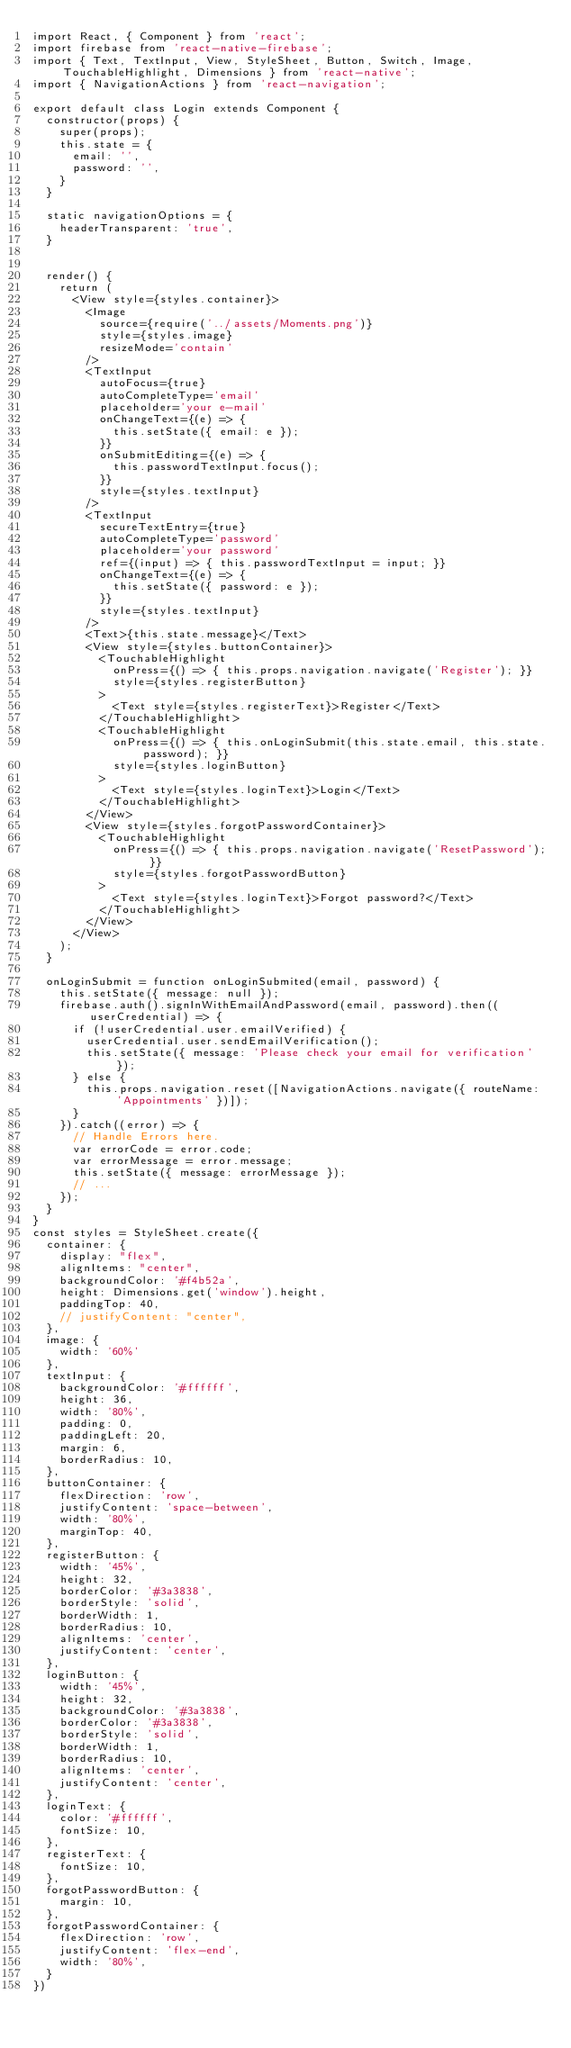<code> <loc_0><loc_0><loc_500><loc_500><_JavaScript_>import React, { Component } from 'react';
import firebase from 'react-native-firebase';
import { Text, TextInput, View, StyleSheet, Button, Switch, Image, TouchableHighlight, Dimensions } from 'react-native';
import { NavigationActions } from 'react-navigation';

export default class Login extends Component {
  constructor(props) {
    super(props);
    this.state = {
      email: '',
      password: '',
    }
  }

  static navigationOptions = {
    headerTransparent: 'true',
  }


  render() {
    return (
      <View style={styles.container}>
        <Image
          source={require('../assets/Moments.png')}
          style={styles.image}
          resizeMode='contain'
        />
        <TextInput
          autoFocus={true}
          autoCompleteType='email'
          placeholder='your e-mail'
          onChangeText={(e) => {
            this.setState({ email: e });
          }}
          onSubmitEditing={(e) => {
            this.passwordTextInput.focus();
          }}
          style={styles.textInput}
        />
        <TextInput
          secureTextEntry={true}
          autoCompleteType='password'
          placeholder='your password'
          ref={(input) => { this.passwordTextInput = input; }}
          onChangeText={(e) => {
            this.setState({ password: e });
          }}
          style={styles.textInput}
        />
        <Text>{this.state.message}</Text>
        <View style={styles.buttonContainer}>
          <TouchableHighlight
            onPress={() => { this.props.navigation.navigate('Register'); }}
            style={styles.registerButton}
          >
            <Text style={styles.registerText}>Register</Text>
          </TouchableHighlight>
          <TouchableHighlight
            onPress={() => { this.onLoginSubmit(this.state.email, this.state.password); }}
            style={styles.loginButton}
          >
            <Text style={styles.loginText}>Login</Text>
          </TouchableHighlight>
        </View>
        <View style={styles.forgotPasswordContainer}>
          <TouchableHighlight
            onPress={() => { this.props.navigation.navigate('ResetPassword'); }}
            style={styles.forgotPasswordButton}
          >
            <Text style={styles.loginText}>Forgot password?</Text>
          </TouchableHighlight>
        </View>
      </View>
    );
  }

  onLoginSubmit = function onLoginSubmited(email, password) {
    this.setState({ message: null });
    firebase.auth().signInWithEmailAndPassword(email, password).then((userCredential) => {
      if (!userCredential.user.emailVerified) {
        userCredential.user.sendEmailVerification();
        this.setState({ message: 'Please check your email for verification' });
      } else {
        this.props.navigation.reset([NavigationActions.navigate({ routeName: 'Appointments' })]);
      }
    }).catch((error) => {
      // Handle Errors here.
      var errorCode = error.code;
      var errorMessage = error.message;
      this.setState({ message: errorMessage });
      // ...
    });
  }
}
const styles = StyleSheet.create({
  container: {
    display: "flex",
    alignItems: "center",
    backgroundColor: '#f4b52a',
    height: Dimensions.get('window').height,
    paddingTop: 40,
    // justifyContent: "center",
  },
  image: {
    width: '60%'
  },
  textInput: {
    backgroundColor: '#ffffff',
    height: 36,
    width: '80%',
    padding: 0,
    paddingLeft: 20,
    margin: 6,
    borderRadius: 10,
  },
  buttonContainer: {
    flexDirection: 'row',
    justifyContent: 'space-between',
    width: '80%',
    marginTop: 40,
  },
  registerButton: {
    width: '45%',
    height: 32,
    borderColor: '#3a3838',
    borderStyle: 'solid',
    borderWidth: 1,
    borderRadius: 10,
    alignItems: 'center',
    justifyContent: 'center',
  },
  loginButton: {
    width: '45%',
    height: 32,
    backgroundColor: '#3a3838',
    borderColor: '#3a3838',
    borderStyle: 'solid',
    borderWidth: 1,
    borderRadius: 10,
    alignItems: 'center',
    justifyContent: 'center',
  },
  loginText: {
    color: '#ffffff',
    fontSize: 10,
  },
  registerText: {
    fontSize: 10,
  },
  forgotPasswordButton: {
    margin: 10,
  },
  forgotPasswordContainer: {
    flexDirection: 'row',
    justifyContent: 'flex-end',
    width: '80%',
  }
})
</code> 